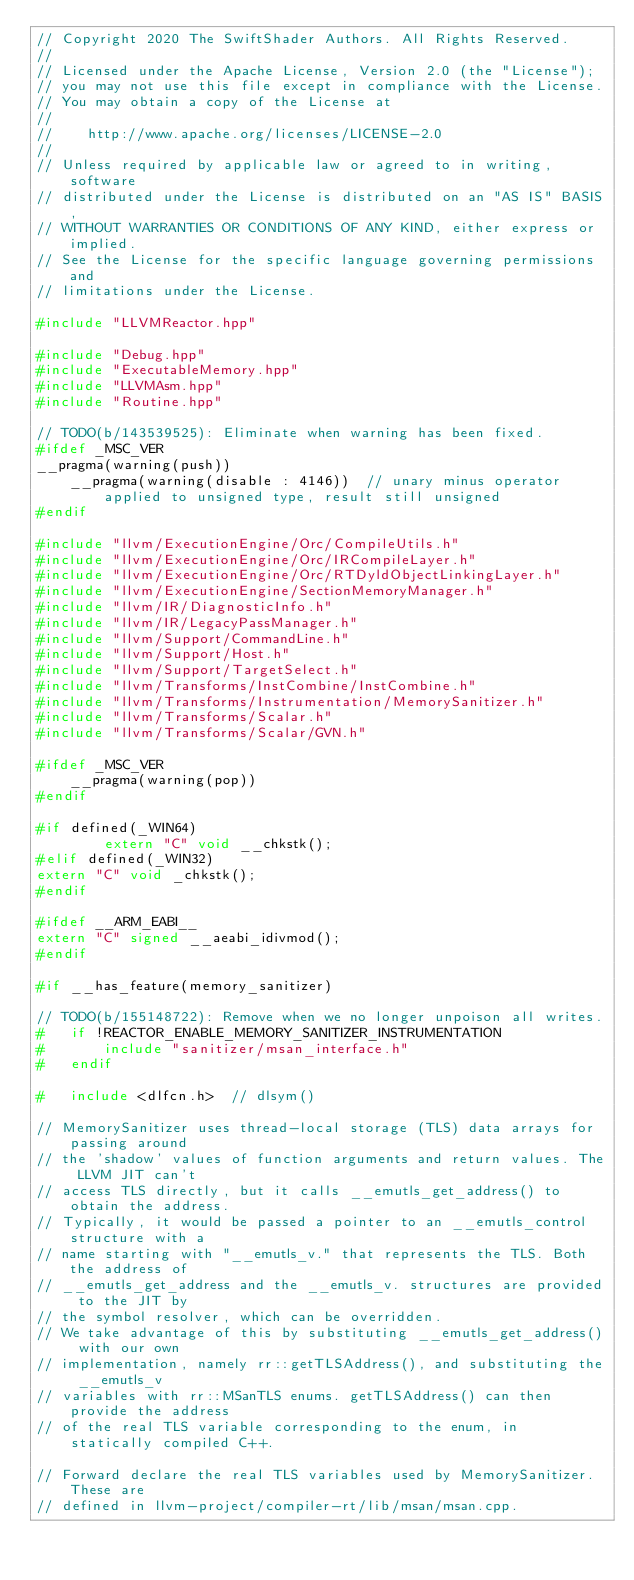Convert code to text. <code><loc_0><loc_0><loc_500><loc_500><_C++_>// Copyright 2020 The SwiftShader Authors. All Rights Reserved.
//
// Licensed under the Apache License, Version 2.0 (the "License");
// you may not use this file except in compliance with the License.
// You may obtain a copy of the License at
//
//    http://www.apache.org/licenses/LICENSE-2.0
//
// Unless required by applicable law or agreed to in writing, software
// distributed under the License is distributed on an "AS IS" BASIS,
// WITHOUT WARRANTIES OR CONDITIONS OF ANY KIND, either express or implied.
// See the License for the specific language governing permissions and
// limitations under the License.

#include "LLVMReactor.hpp"

#include "Debug.hpp"
#include "ExecutableMemory.hpp"
#include "LLVMAsm.hpp"
#include "Routine.hpp"

// TODO(b/143539525): Eliminate when warning has been fixed.
#ifdef _MSC_VER
__pragma(warning(push))
    __pragma(warning(disable : 4146))  // unary minus operator applied to unsigned type, result still unsigned
#endif

#include "llvm/ExecutionEngine/Orc/CompileUtils.h"
#include "llvm/ExecutionEngine/Orc/IRCompileLayer.h"
#include "llvm/ExecutionEngine/Orc/RTDyldObjectLinkingLayer.h"
#include "llvm/ExecutionEngine/SectionMemoryManager.h"
#include "llvm/IR/DiagnosticInfo.h"
#include "llvm/IR/LegacyPassManager.h"
#include "llvm/Support/CommandLine.h"
#include "llvm/Support/Host.h"
#include "llvm/Support/TargetSelect.h"
#include "llvm/Transforms/InstCombine/InstCombine.h"
#include "llvm/Transforms/Instrumentation/MemorySanitizer.h"
#include "llvm/Transforms/Scalar.h"
#include "llvm/Transforms/Scalar/GVN.h"

#ifdef _MSC_VER
    __pragma(warning(pop))
#endif

#if defined(_WIN64)
        extern "C" void __chkstk();
#elif defined(_WIN32)
extern "C" void _chkstk();
#endif

#ifdef __ARM_EABI__
extern "C" signed __aeabi_idivmod();
#endif

#if __has_feature(memory_sanitizer)

// TODO(b/155148722): Remove when we no longer unpoison all writes.
#	if !REACTOR_ENABLE_MEMORY_SANITIZER_INSTRUMENTATION
#		include "sanitizer/msan_interface.h"
#	endif

#	include <dlfcn.h>  // dlsym()

// MemorySanitizer uses thread-local storage (TLS) data arrays for passing around
// the 'shadow' values of function arguments and return values. The LLVM JIT can't
// access TLS directly, but it calls __emutls_get_address() to obtain the address.
// Typically, it would be passed a pointer to an __emutls_control structure with a
// name starting with "__emutls_v." that represents the TLS. Both the address of
// __emutls_get_address and the __emutls_v. structures are provided to the JIT by
// the symbol resolver, which can be overridden.
// We take advantage of this by substituting __emutls_get_address() with our own
// implementation, namely rr::getTLSAddress(), and substituting the __emutls_v
// variables with rr::MSanTLS enums. getTLSAddress() can then provide the address
// of the real TLS variable corresponding to the enum, in statically compiled C++.

// Forward declare the real TLS variables used by MemorySanitizer. These are
// defined in llvm-project/compiler-rt/lib/msan/msan.cpp.</code> 